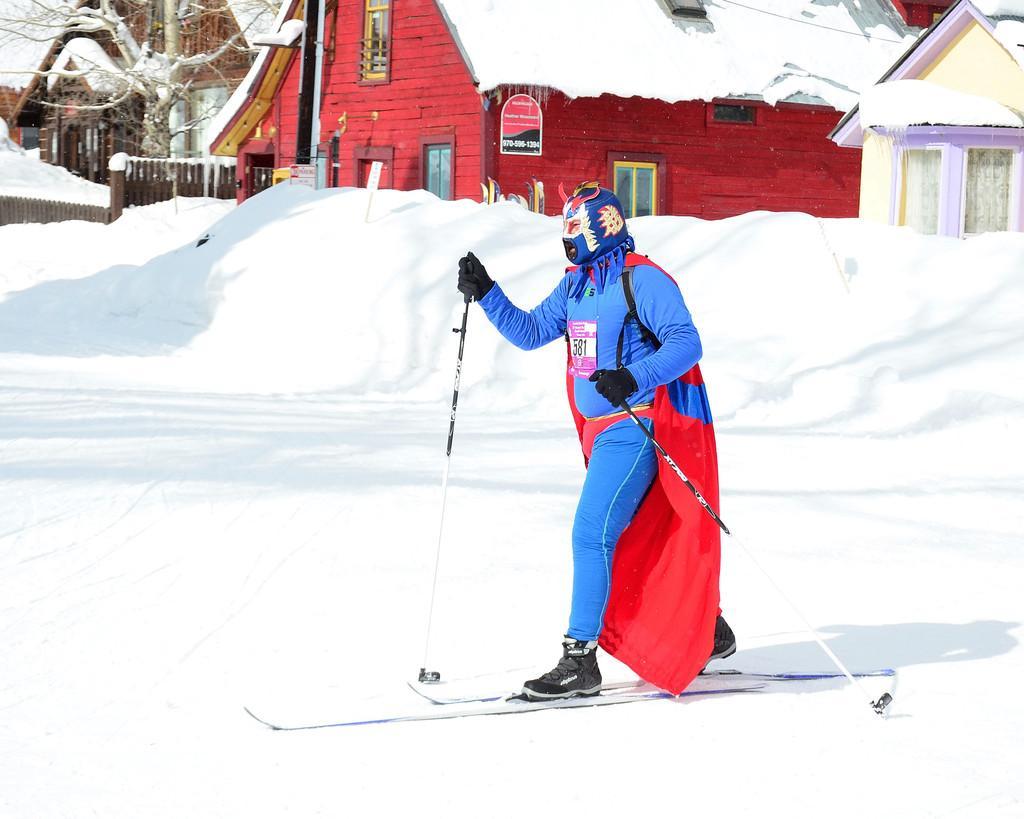Please provide a concise description of this image. There is a person skiing on the snow with ski boards and holding sticks and wore costume. In the background we can see houses, tree and wooden fence. 